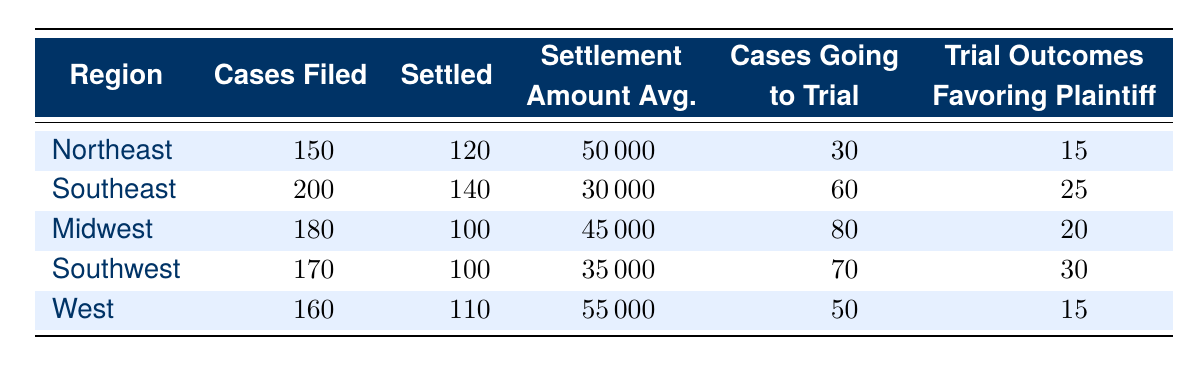What is the average settlement amount in the Northeast region? The average settlement amount for the Northeast region is provided in the table as 50000.
Answer: 50000 How many cases were filed in the Southeast region? The table states that 200 cases were filed in the Southeast region.
Answer: 200 Which region had the highest number of cases filed? By comparing the 'Cases Filed' column, the Southeast region has the highest number at 200.
Answer: Southeast What is the total number of cases settled across all regions? Adding the 'Settled' values together: 120 (Northeast) + 140 (Southeast) + 100 (Midwest) + 100 (Southwest) + 110 (West) = 670.
Answer: 670 Did the Midwest have more cases settled than the Southwest? The Midwest had 100 cases settled while the Southwest also had 100 settled cases, indicating they are equal.
Answer: No Which region has the lowest average settlement amount? The average settlement amounts are 50000 (Northeast), 30000 (Southeast), 45000 (Midwest), 35000 (Southwest), and 55000 (West). The Southeast has the lowest at 30000.
Answer: Southeast If we compare the average settlements between the Northeast and the West, which one is higher? The average settlement in the Northeast is 50000, while in the West it is 55000. Therefore, the West has a higher average settlement.
Answer: West How many trials were there in total across all regions? The total number of cases going to trial can be calculated by adding the relevant column: 30 (Northeast) + 60 (Southeast) + 80 (Midwest) + 70 (Southwest) + 50 (West) = 290.
Answer: 290 What percentage of cases filed in the Southwest region were settled? The percentage can be calculated using (Settled / Cases Filed) * 100. Thus, (100 / 170) * 100 = 58.82%.
Answer: 58.82% 